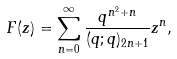<formula> <loc_0><loc_0><loc_500><loc_500>F ( z ) = \sum _ { n = 0 } ^ { \infty } \frac { q ^ { n ^ { 2 } + n } } { ( q ; q ) _ { 2 n + 1 } } z ^ { n } ,</formula> 